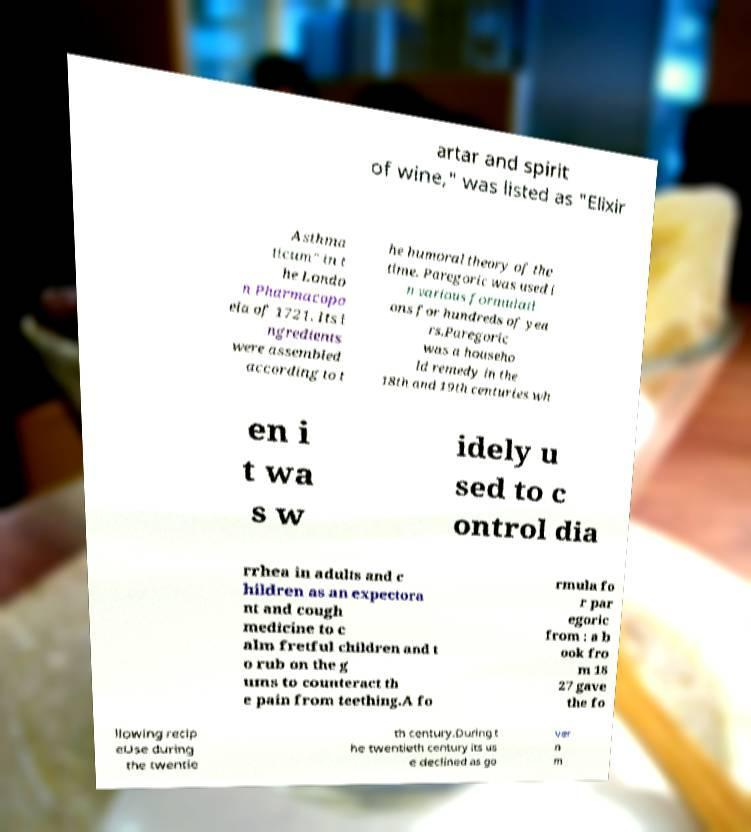Please identify and transcribe the text found in this image. artar and spirit of wine," was listed as "Elixir Asthma ticum" in t he Londo n Pharmacopo eia of 1721. Its i ngredients were assembled according to t he humoral theory of the time. Paregoric was used i n various formulati ons for hundreds of yea rs.Paregoric was a househo ld remedy in the 18th and 19th centuries wh en i t wa s w idely u sed to c ontrol dia rrhea in adults and c hildren as an expectora nt and cough medicine to c alm fretful children and t o rub on the g ums to counteract th e pain from teething.A fo rmula fo r par egoric from : a b ook fro m 18 27 gave the fo llowing recip eUse during the twentie th century.During t he twentieth century its us e declined as go ver n m 